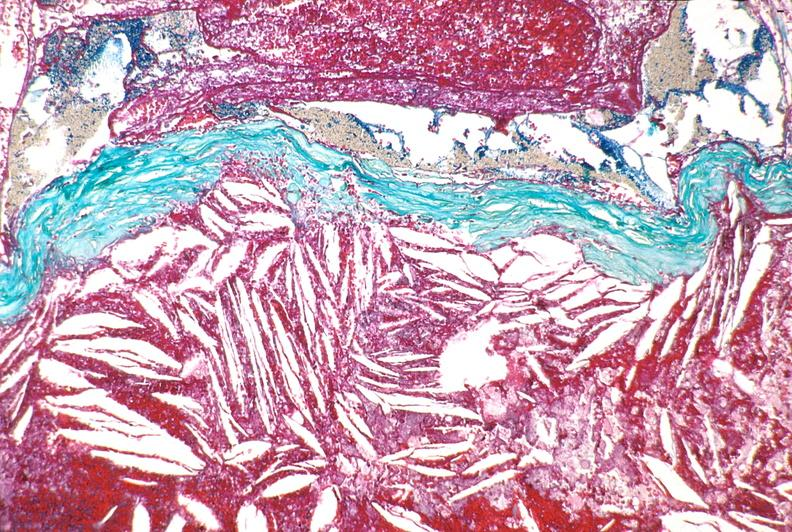what is present?
Answer the question using a single word or phrase. Cardiovascular 